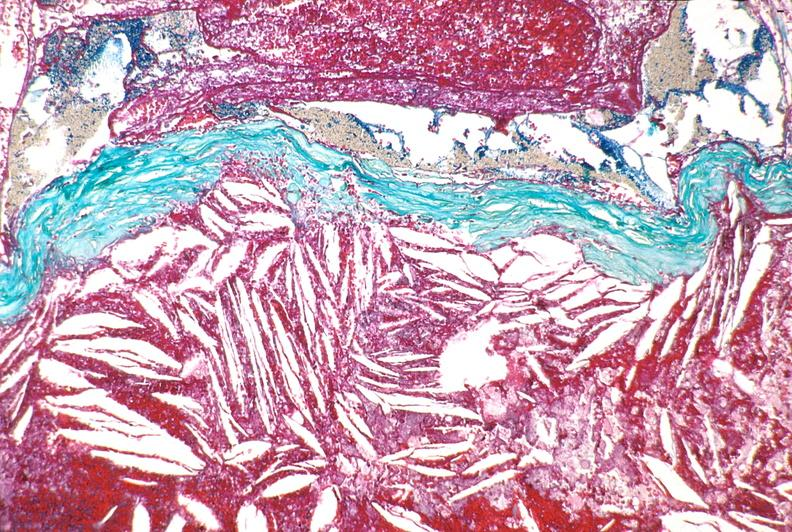what is present?
Answer the question using a single word or phrase. Cardiovascular 